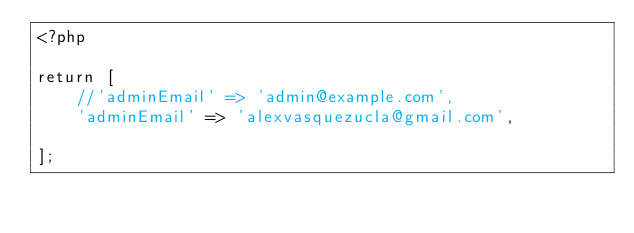<code> <loc_0><loc_0><loc_500><loc_500><_PHP_><?php

return [
    //'adminEmail' => 'admin@example.com',
    'adminEmail' => 'alexvasquezucla@gmail.com',

];
</code> 